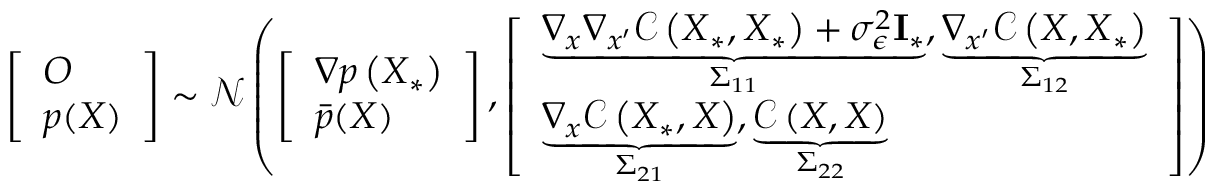Convert formula to latex. <formula><loc_0><loc_0><loc_500><loc_500>\left [ \begin{array} { l } { O } \\ { p ( X ) } \end{array} \right ] \sim \mathcal { N } \left ( \left [ \begin{array} { l } { \nabla p \left ( X _ { * } \right ) } \\ { \bar { p } ( X ) } \end{array} \right ] , \left [ \begin{array} { l } { \underbrace { \nabla _ { x } \nabla _ { x ^ { \prime } } \mathcal { C } \left ( X _ { * } , X _ { * } \right ) + \sigma _ { \epsilon } ^ { 2 } I _ { * } } _ { \Sigma _ { 1 1 } } , \underbrace { \nabla _ { x ^ { \prime } } \mathcal { C } \left ( X , X _ { * } \right ) } _ { \Sigma _ { 1 2 } } } \\ { \underbrace { \nabla _ { x } \mathcal { C } \left ( X _ { * } , X \right ) } _ { \Sigma _ { 2 1 } } , \underbrace { \mathcal { C } \left ( X , X \right ) } _ { \Sigma _ { 2 2 } } } \end{array} \right ] \right )</formula> 